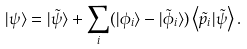<formula> <loc_0><loc_0><loc_500><loc_500>| \psi \rangle = | \tilde { \psi } \rangle + \sum _ { i } ( | \phi _ { i } \rangle - | \tilde { \phi } _ { i } \rangle ) \left \langle \tilde { p } _ { i } | \tilde { \psi } \right \rangle .</formula> 